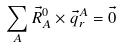<formula> <loc_0><loc_0><loc_500><loc_500>\sum _ { A } \vec { R } _ { A } ^ { 0 } \times \vec { q } _ { r } ^ { A } = \vec { 0 }</formula> 